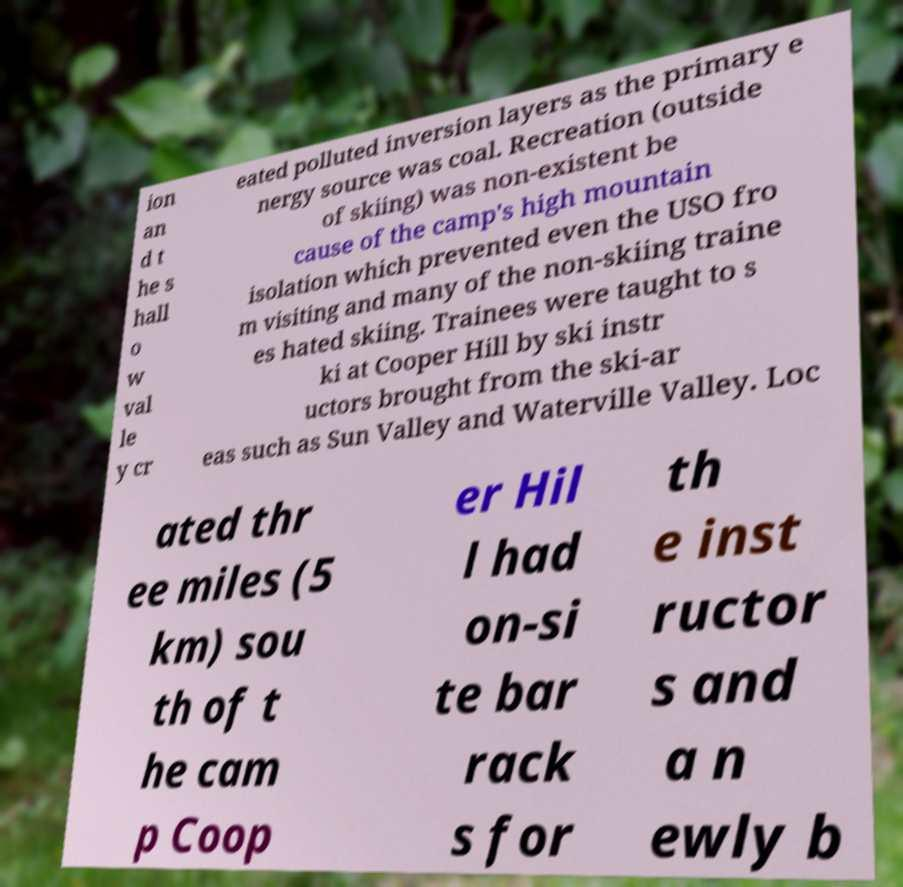Can you read and provide the text displayed in the image?This photo seems to have some interesting text. Can you extract and type it out for me? ion an d t he s hall o w val le y cr eated polluted inversion layers as the primary e nergy source was coal. Recreation (outside of skiing) was non-existent be cause of the camp's high mountain isolation which prevented even the USO fro m visiting and many of the non-skiing traine es hated skiing. Trainees were taught to s ki at Cooper Hill by ski instr uctors brought from the ski-ar eas such as Sun Valley and Waterville Valley. Loc ated thr ee miles (5 km) sou th of t he cam p Coop er Hil l had on-si te bar rack s for th e inst ructor s and a n ewly b 